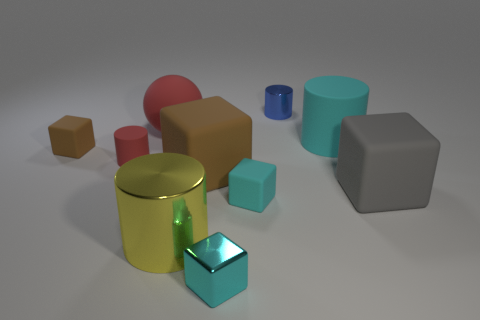How many things are either big metallic things or large green shiny objects?
Make the answer very short. 1. Is the number of large things that are in front of the small brown matte cube the same as the number of shiny things?
Make the answer very short. Yes. There is a tiny metal thing that is in front of the metal cylinder that is in front of the gray object; is there a brown rubber block that is right of it?
Your response must be concise. No. What color is the small cylinder that is made of the same material as the big cyan cylinder?
Offer a very short reply. Red. Is the color of the tiny rubber object in front of the tiny matte cylinder the same as the small shiny block?
Your answer should be very brief. Yes. What number of blocks are cyan things or tiny objects?
Your answer should be compact. 3. What size is the yellow object in front of the tiny cyan cube behind the small shiny thing in front of the blue shiny cylinder?
Keep it short and to the point. Large. The gray thing that is the same size as the cyan cylinder is what shape?
Give a very brief answer. Cube. The big cyan matte thing is what shape?
Offer a terse response. Cylinder. Is the large object to the left of the big yellow metal cylinder made of the same material as the big gray cube?
Keep it short and to the point. Yes. 